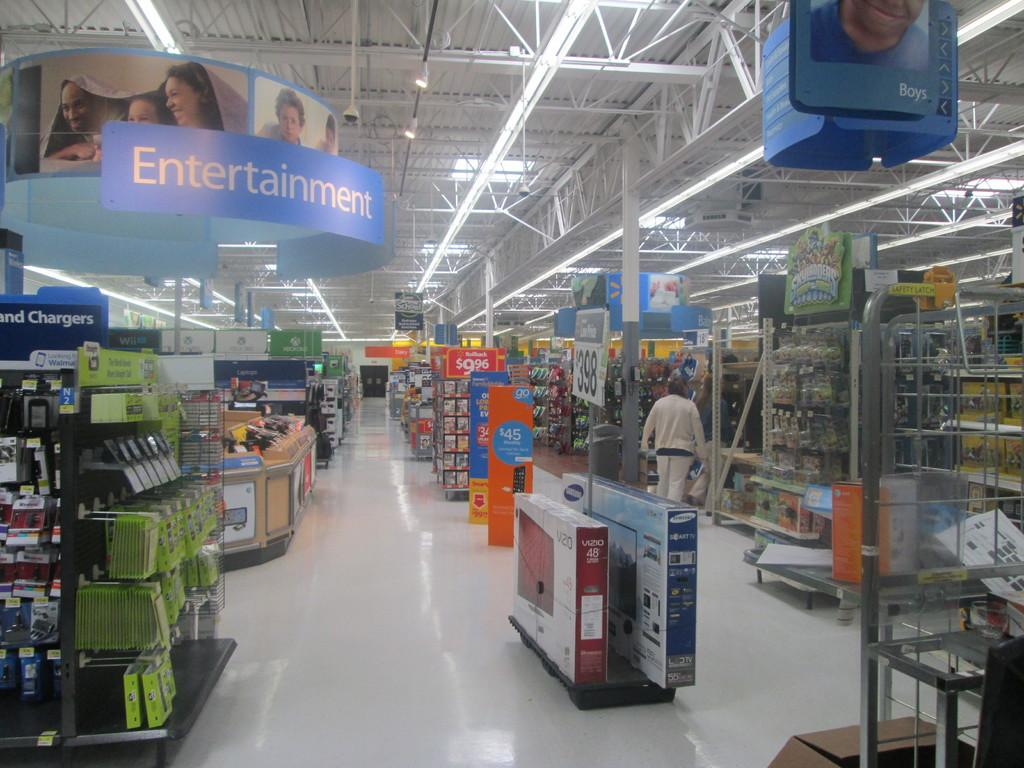<image>
Summarize the visual content of the image. A sign showing where the Entertainment section of the store is at 